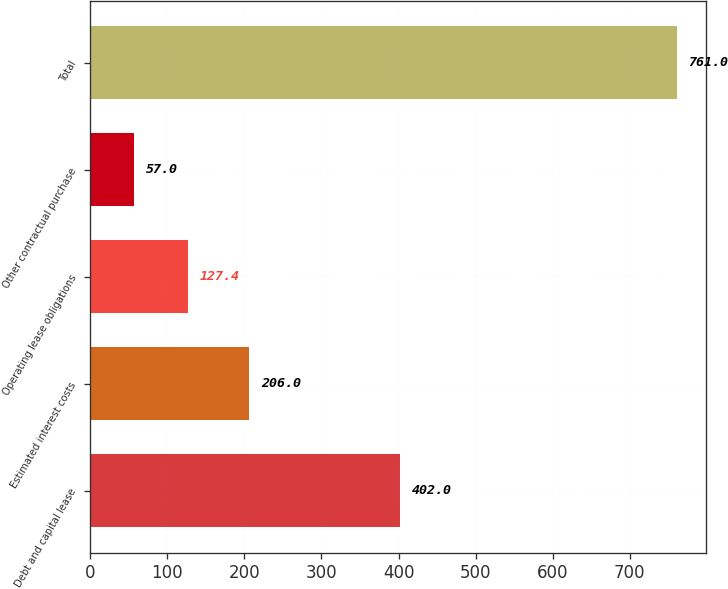Convert chart. <chart><loc_0><loc_0><loc_500><loc_500><bar_chart><fcel>Debt and capital lease<fcel>Estimated interest costs<fcel>Operating lease obligations<fcel>Other contractual purchase<fcel>Total<nl><fcel>402<fcel>206<fcel>127.4<fcel>57<fcel>761<nl></chart> 